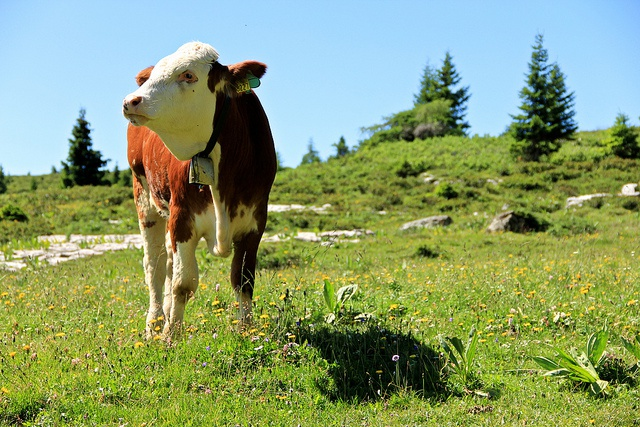Describe the objects in this image and their specific colors. I can see a cow in lightblue, black, olive, and ivory tones in this image. 